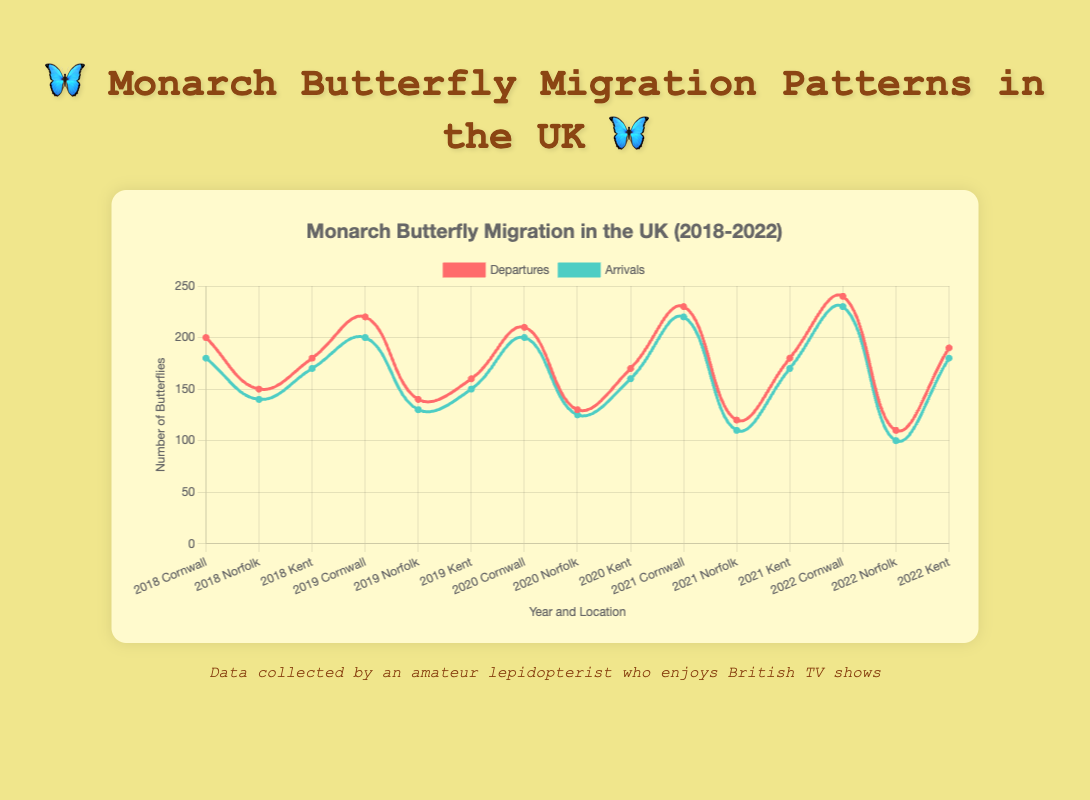What year did Cornwall have the highest number of departures? Look at the line for departures for Cornwall from 2018 to 2022. The highest point on that line indicates the highest number of departures. The year with the highest number is 240 in 2022.
Answer: 2022 In which location did the departures increase consistently from 2018 to 2022? Check the trends for departures in Cornwall, Norfolk, and Kent from 2018 to 2022. In Cornwall, the number of departing butterflies increased every year: 200, 220, 210, 230, 240.
Answer: Cornwall What is the average number of departures in Norfolk over the years? Sum the departures from Norfolk over the years (150 + 140 + 130 + 120 + 110) and divide by the number of years (5). The sum is 650, so the average is 650/5.
Answer: 130 Which year had the largest gap between departures and arrivals in Kent? Calculate the gaps for each year in Kent: 10 in 2018, 10 in 2019, 10 in 2020, 10 in 2021, 10 in 2022. The gaps are equal, so pick any year.
Answer: Any year (all gaps are the same) Compare Cornwall and Norfolk: which one had higher arrivals in 2019? Look at the arrival numbers for both locations in 2019. Cornwall had 200 arrivals, Norfolk had 130. Cornwall's arrivals are clearly higher.
Answer: Cornwall What is the peak migration date in Norfolk for 2021? Locate the data point for Norfolk in 2021 and read the peak migration date. The date is 2021-09-19.
Answer: 2021-09-19 What is the range of departures for Kent from 2018 to 2022? Identify the smallest and largest number of departures in Kent during these years: lowest is 160 in 2019 and highest is 190 in 2022. Subtract the lowest from the highest: 190 - 160.
Answer: 30 Which location had the least consistent number of arrivals from 2020 to 2022? Observe the trends in the arrivals from 2020 to 2022. Compare the fluctuations across Cornwall (200, 220, 230), Norfolk (125, 110, 100), and Kent (160, 170, 180). Norfolk shows the greatest decline from 125 to 100.
Answer: Norfolk What was the peak migration date in Cornwall in 2020? Check the peak migration date noted for Cornwall in 2020. It is listed as 2020-09-12.
Answer: 2020-09-12 